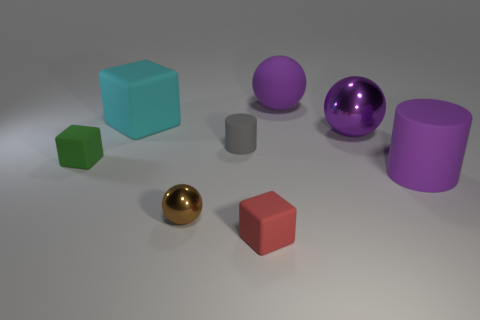Are there any large metal balls that have the same color as the big rubber cylinder?
Offer a very short reply. Yes. Does the matte ball have the same color as the large matte object that is in front of the small green thing?
Give a very brief answer. Yes. There is a cube to the right of the ball that is to the left of the large purple matte sphere; what is its size?
Keep it short and to the point. Small. Are there the same number of gray cylinders that are to the left of the tiny shiny ball and gray cylinders in front of the green block?
Your answer should be compact. Yes. There is a matte cube that is to the right of the big cyan cube; are there any large objects that are to the right of it?
Your answer should be very brief. Yes. What shape is the gray object that is the same material as the red thing?
Your answer should be very brief. Cylinder. Are there any other things that are the same color as the big shiny thing?
Provide a short and direct response. Yes. What material is the purple sphere behind the shiny sphere right of the tiny brown metal thing made of?
Keep it short and to the point. Rubber. Is there a small gray matte object of the same shape as the red matte object?
Ensure brevity in your answer.  No. How many other things are the same shape as the brown metallic thing?
Provide a succinct answer. 2. 